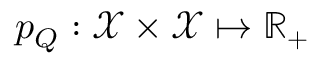<formula> <loc_0><loc_0><loc_500><loc_500>p _ { Q } \colon \mathcal { X } \times \mathcal { X } \mapsto \mathbb { R } _ { + }</formula> 